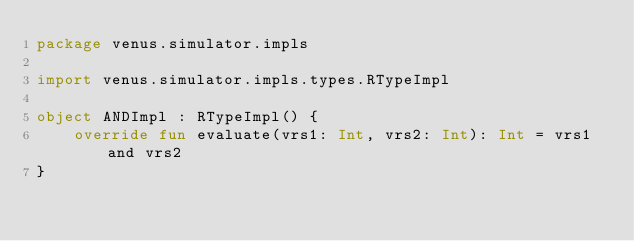Convert code to text. <code><loc_0><loc_0><loc_500><loc_500><_Kotlin_>package venus.simulator.impls

import venus.simulator.impls.types.RTypeImpl

object ANDImpl : RTypeImpl() {
    override fun evaluate(vrs1: Int, vrs2: Int): Int = vrs1 and vrs2
}
</code> 